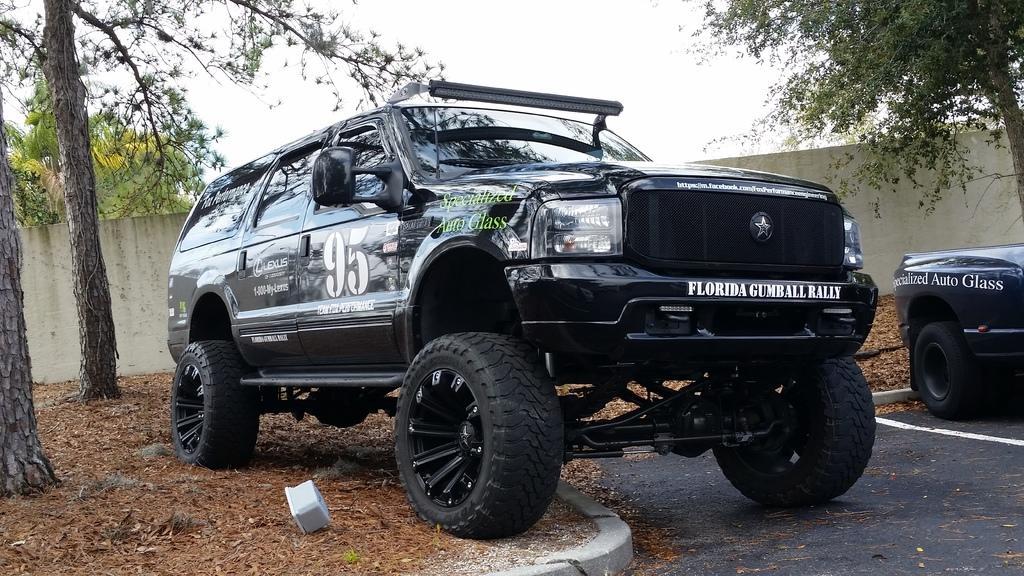Can you describe this image briefly? In the foreground of this image, there is a vehicle half on the road and half on the ground and there is also a vehicle on the right. In the background, there trees, wall and the sky. 